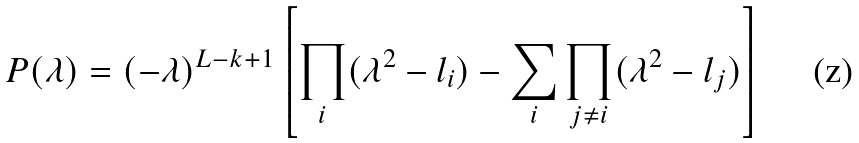<formula> <loc_0><loc_0><loc_500><loc_500>P ( \lambda ) = ( - \lambda ) ^ { L - k + 1 } \left [ \prod _ { i } ( \lambda ^ { 2 } - l _ { i } ) - \sum _ { i } \prod _ { j \ne i } ( \lambda ^ { 2 } - l _ { j } ) \right ]</formula> 